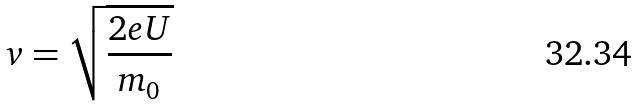<formula> <loc_0><loc_0><loc_500><loc_500>v = \sqrt { \frac { 2 e U } { m _ { 0 } } }</formula> 